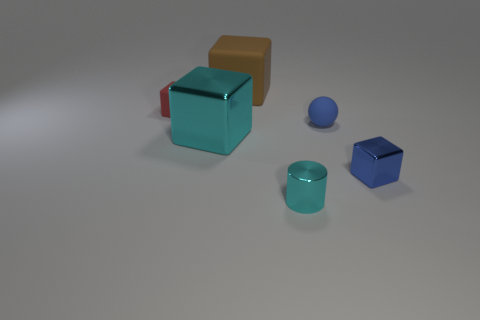There is a shiny object that is the same size as the cylinder; what is its color?
Offer a terse response. Blue. Are there any small shiny blocks that have the same color as the small rubber cube?
Provide a short and direct response. No. Are there any brown shiny spheres?
Give a very brief answer. No. Are the tiny blue object that is behind the blue shiny object and the cyan cylinder made of the same material?
Ensure brevity in your answer.  No. There is a block that is the same color as the cylinder; what size is it?
Make the answer very short. Large. How many other metal things have the same size as the brown thing?
Your answer should be very brief. 1. Is the number of small blocks to the left of the small cylinder the same as the number of large rubber blocks?
Your response must be concise. Yes. How many cubes are in front of the small rubber ball and on the left side of the small shiny block?
Offer a terse response. 1. What size is the sphere that is made of the same material as the big brown thing?
Offer a very short reply. Small. How many brown matte objects are the same shape as the tiny blue metal object?
Your answer should be very brief. 1. 